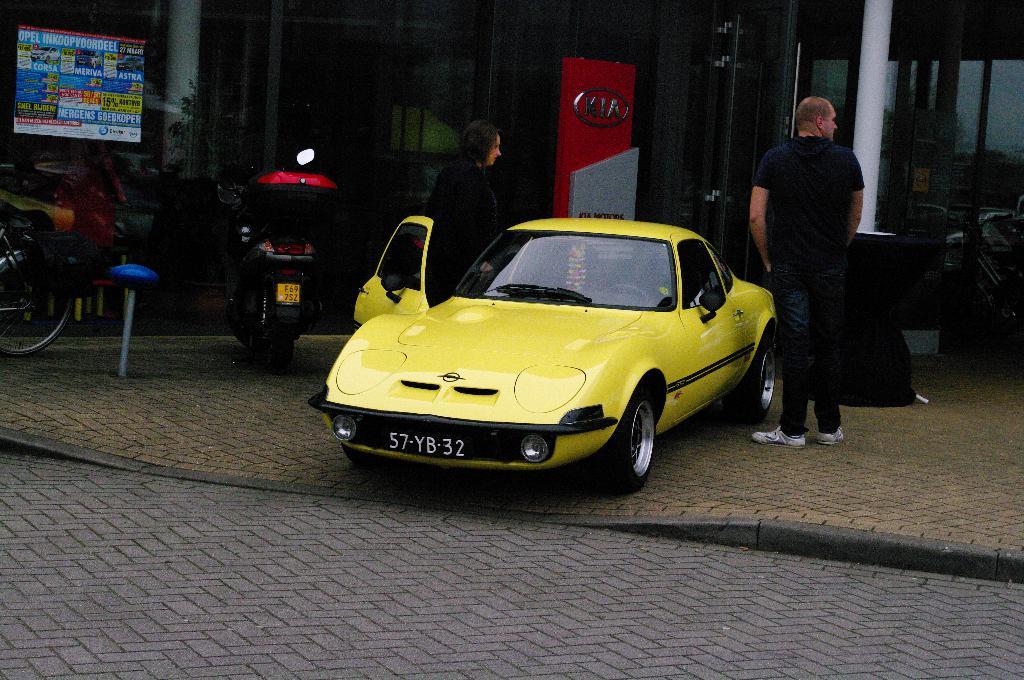What is the license number of the yellow car?
Your answer should be compact. 57-yb-32. 